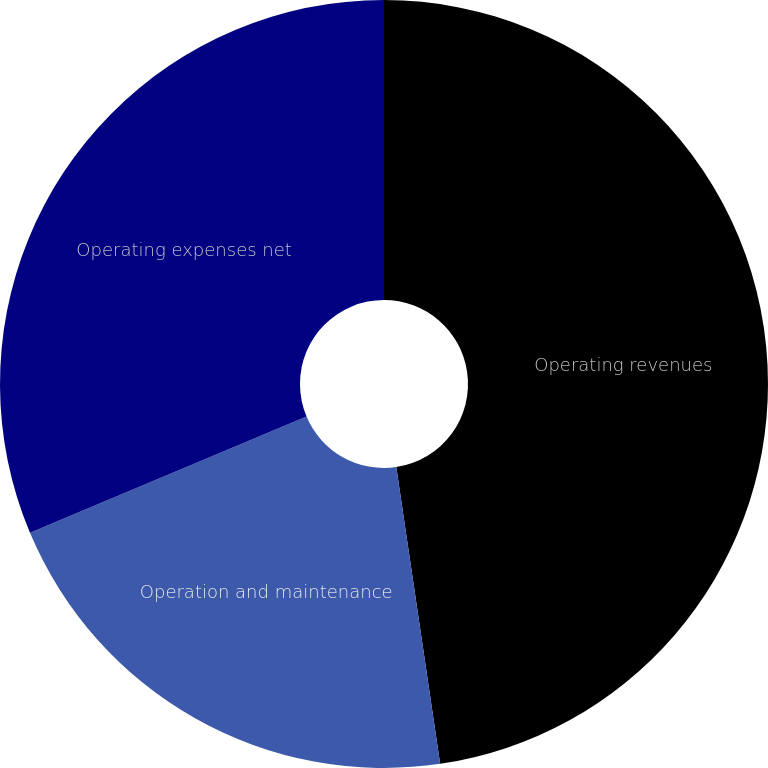Convert chart. <chart><loc_0><loc_0><loc_500><loc_500><pie_chart><fcel>Operating revenues<fcel>Operation and maintenance<fcel>Operating expenses net<nl><fcel>47.66%<fcel>21.0%<fcel>31.33%<nl></chart> 